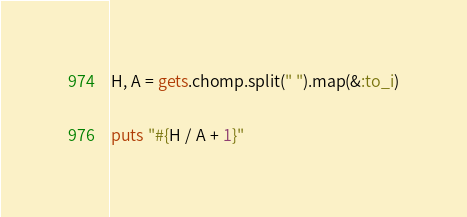Convert code to text. <code><loc_0><loc_0><loc_500><loc_500><_Ruby_>H, A = gets.chomp.split(" ").map(&:to_i)

puts "#{H / A + 1}"</code> 